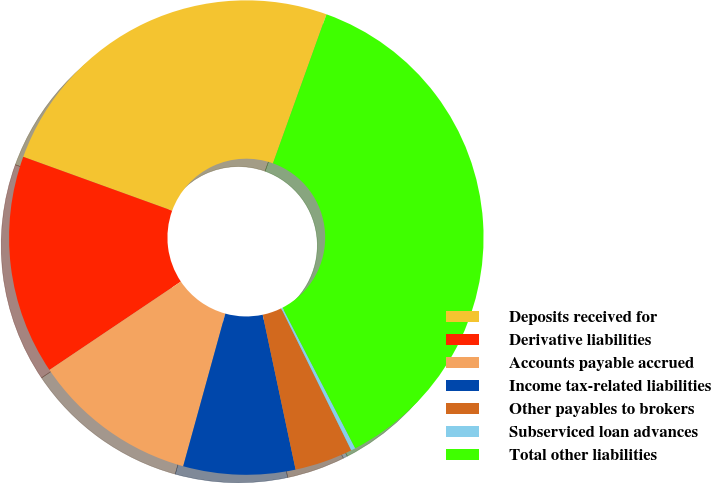Convert chart. <chart><loc_0><loc_0><loc_500><loc_500><pie_chart><fcel>Deposits received for<fcel>Derivative liabilities<fcel>Accounts payable accrued<fcel>Income tax-related liabilities<fcel>Other payables to brokers<fcel>Subserviced loan advances<fcel>Total other liabilities<nl><fcel>24.96%<fcel>14.95%<fcel>11.29%<fcel>7.62%<fcel>3.96%<fcel>0.3%<fcel>36.92%<nl></chart> 